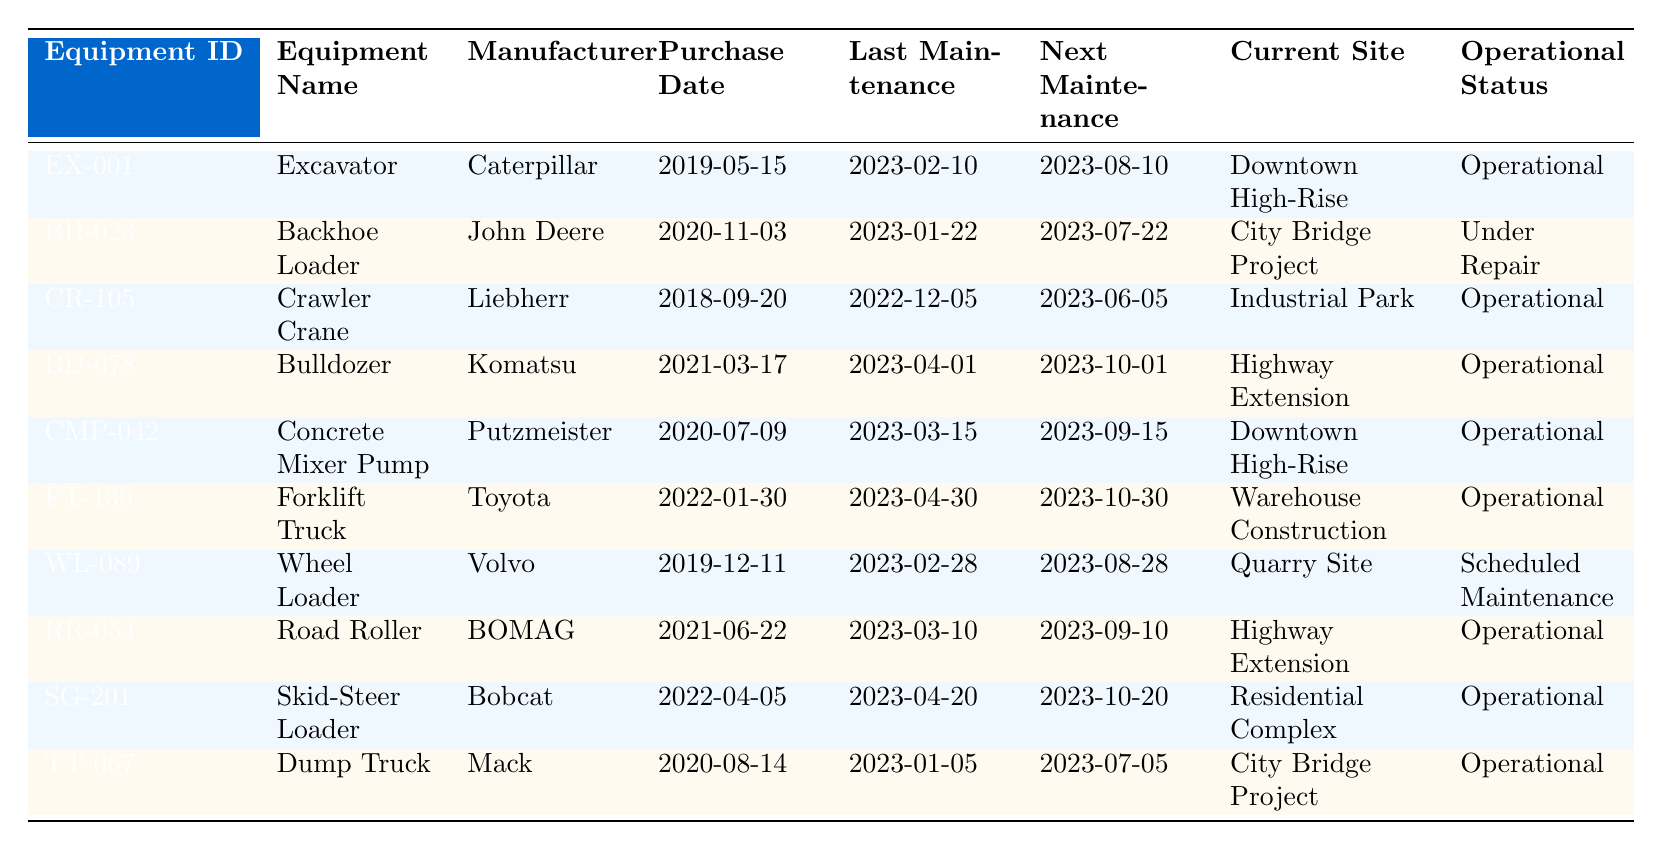What is the operational status of the Excavator? Looking at the table, the row for the Excavator (EX-001) indicates "Operational" in the Operational Status column.
Answer: Operational Which equipment has the next maintenance date of 2023-10-01? Referring to the Next Maintenance column, the Bulldozer (BD-078) has the upcoming maintenance scheduled for 2023-10-01.
Answer: Bulldozer How many pieces of equipment are currently 'Under Repair'? Scanning through the Operational Status column, only the Backhoe Loader (BH-023) is marked as 'Under Repair', indicating there is one such piece of equipment.
Answer: 1 What is the purchase date of the Concrete Mixer Pump? The table shows that the Concrete Mixer Pump (CMP-042) was purchased on 2020-07-09, as noted in the Purchase Date column.
Answer: 2020-07-09 Which equipment has the latest last maintenance date, and what is that date? By comparing the Last Maintenance dates for all equipment, the Backhoe Loader (BH-023) has the most recent date, 2023-01-22.
Answer: Backhoe Loader, 2023-01-22 How many equipment pieces have their next maintenance scheduled after 2023-09-15? Looking at the Next Maintenance column, the Forklift Truck (FT-136) and Wheel Loader (WL-089) both have next maintenance dates after 2023-09-15, making a total of two.
Answer: 2 True or False: The Crawler Crane has a next maintenance date in June 2023. The Crawler Crane (CR-105) shows its next maintenance date as 2023-06-05 in the Next Maintenance column, which confirms the statement is true.
Answer: True What is the difference in purchase dates between the Excavator and the Skid-Steer Loader? The Excavator was purchased on 2019-05-15 and the Skid-Steer Loader on 2022-04-05. The difference between these dates is approximately 2 years and 11 months.
Answer: 2 years and 11 months What is the total number of operational pieces of equipment? Counting the Operational Status column, there are 8 pieces of equipment labeled as 'Operational', excluding those under repair or awaiting maintenance.
Answer: 8 Which site has the highest number of operating machinery? Reviewing the Current Site column, both Downtown High-Rise and Highway Extension host two pieces of operational equipment each (Excavator and Concrete Mixer Pump for the former, and Bulldozer and Road Roller for the latter); therefore, they tie for the highest.
Answer: Downtown High-Rise, Highway Extension 